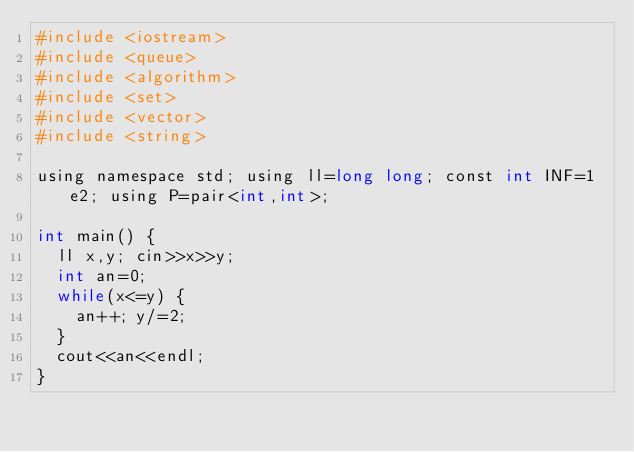<code> <loc_0><loc_0><loc_500><loc_500><_Python_>#include <iostream>
#include <queue>
#include <algorithm>
#include <set>
#include <vector>
#include <string>

using namespace std; using ll=long long; const int INF=1e2; using P=pair<int,int>;

int main() {
  ll x,y; cin>>x>>y;
  int an=0;
  while(x<=y) {
    an++; y/=2;
  }
  cout<<an<<endl;
}</code> 